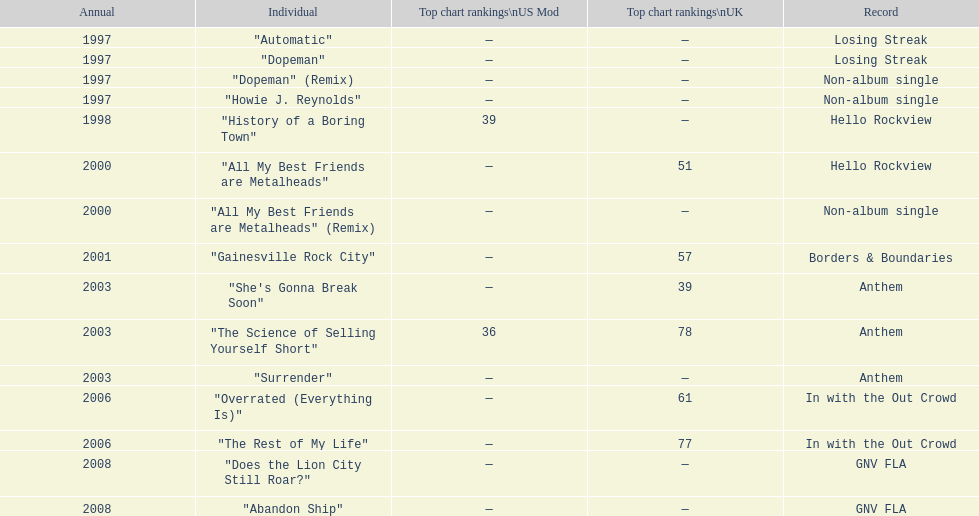Which year has the most singles? 1997. 